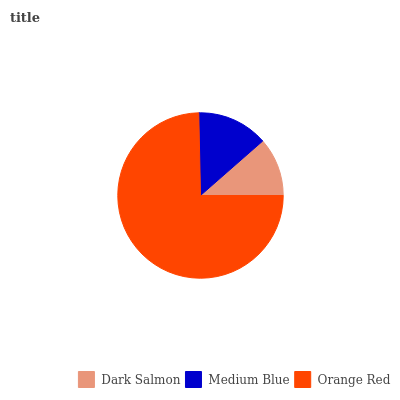Is Dark Salmon the minimum?
Answer yes or no. Yes. Is Orange Red the maximum?
Answer yes or no. Yes. Is Medium Blue the minimum?
Answer yes or no. No. Is Medium Blue the maximum?
Answer yes or no. No. Is Medium Blue greater than Dark Salmon?
Answer yes or no. Yes. Is Dark Salmon less than Medium Blue?
Answer yes or no. Yes. Is Dark Salmon greater than Medium Blue?
Answer yes or no. No. Is Medium Blue less than Dark Salmon?
Answer yes or no. No. Is Medium Blue the high median?
Answer yes or no. Yes. Is Medium Blue the low median?
Answer yes or no. Yes. Is Dark Salmon the high median?
Answer yes or no. No. Is Orange Red the low median?
Answer yes or no. No. 